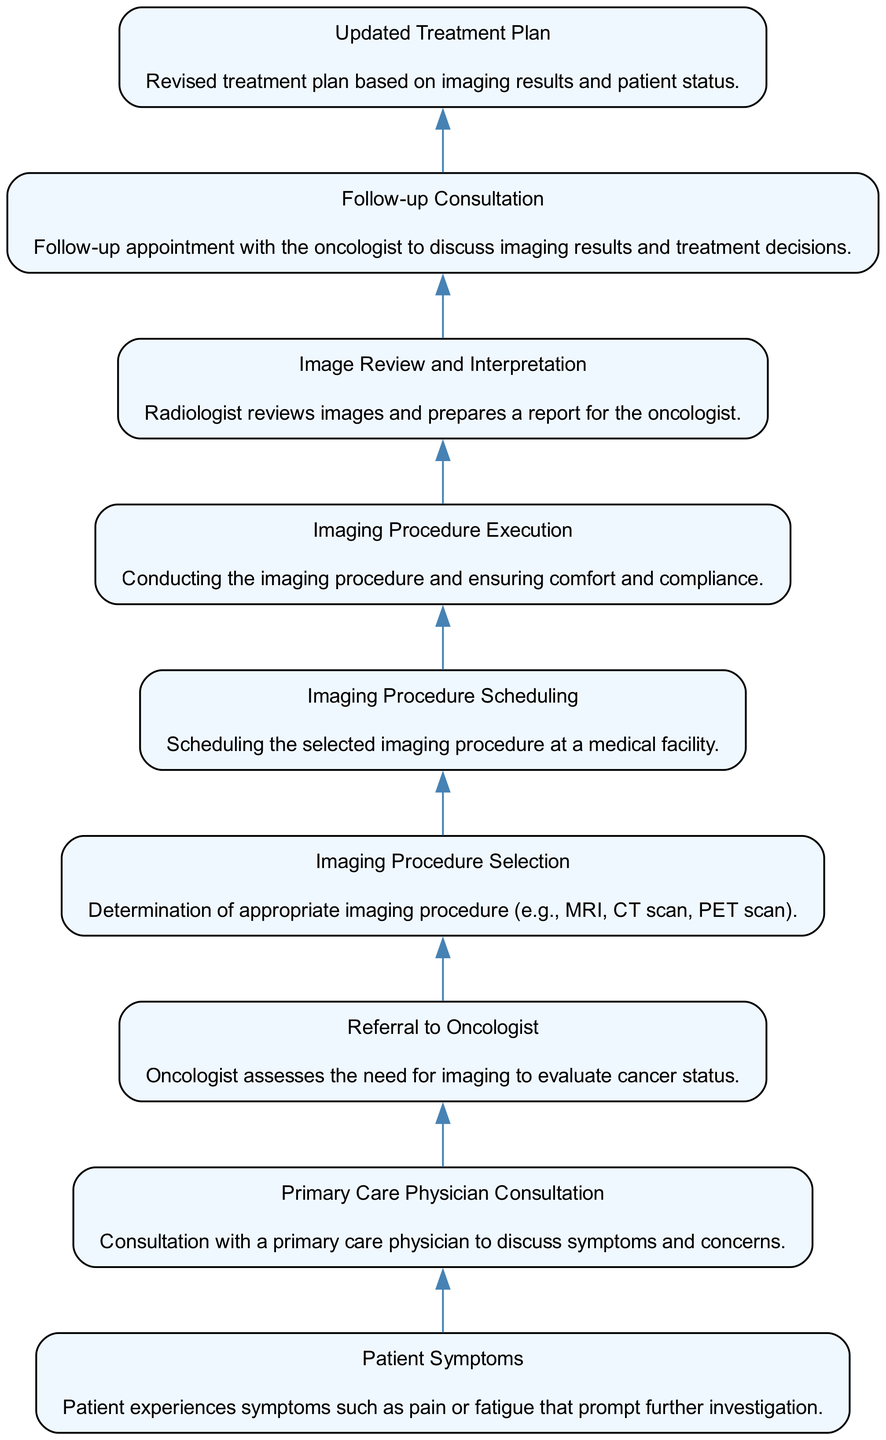What is the first step in the treatment decision pathway? The first step is "Patient Symptoms," as it is the starting point that prompts further investigation based on the patient's experience.
Answer: Patient Symptoms How many main steps are there in the pathway? By counting all the nodes represented in the diagram, we find there are nine distinct main steps throughout the pathway.
Answer: Nine What follows after "Imaging Procedure Execution"? After "Imaging Procedure Execution," the next step is "Image Review and Interpretation," where the radiologist reviews the images.
Answer: Image Review and Interpretation Which node directly leads to the "Updated Treatment Plan"? The "Follow-up Consultation" node directly leads to the "Updated Treatment Plan," where treatment strategies are revised based on the results discussed.
Answer: Follow-up Consultation What do patients discuss with their primary care physician? Patients discuss their "symptoms and concerns" during the consultation with their primary care physician, which is crucial for further assessment.
Answer: Symptoms and concerns Which imaging procedure may be selected in the pathway? Possible imaging procedures include "MRI," "CT scan," and "PET scan," as specified in the node that addresses imaging procedure selection.
Answer: MRI, CT scan, PET scan Does "Referral to Oncologist" come before or after "Primary Care Physician Consultation"? The "Referral to Oncologist" step comes after the "Primary Care Physician Consultation," which suggests that further specialist evaluation is needed.
Answer: After What role does the radiologist play in the process? The radiologist's role is to "review images and prepare a report" for the oncologist, essential for interpreting results and aiding treatment decisions.
Answer: Review images and prepare a report 